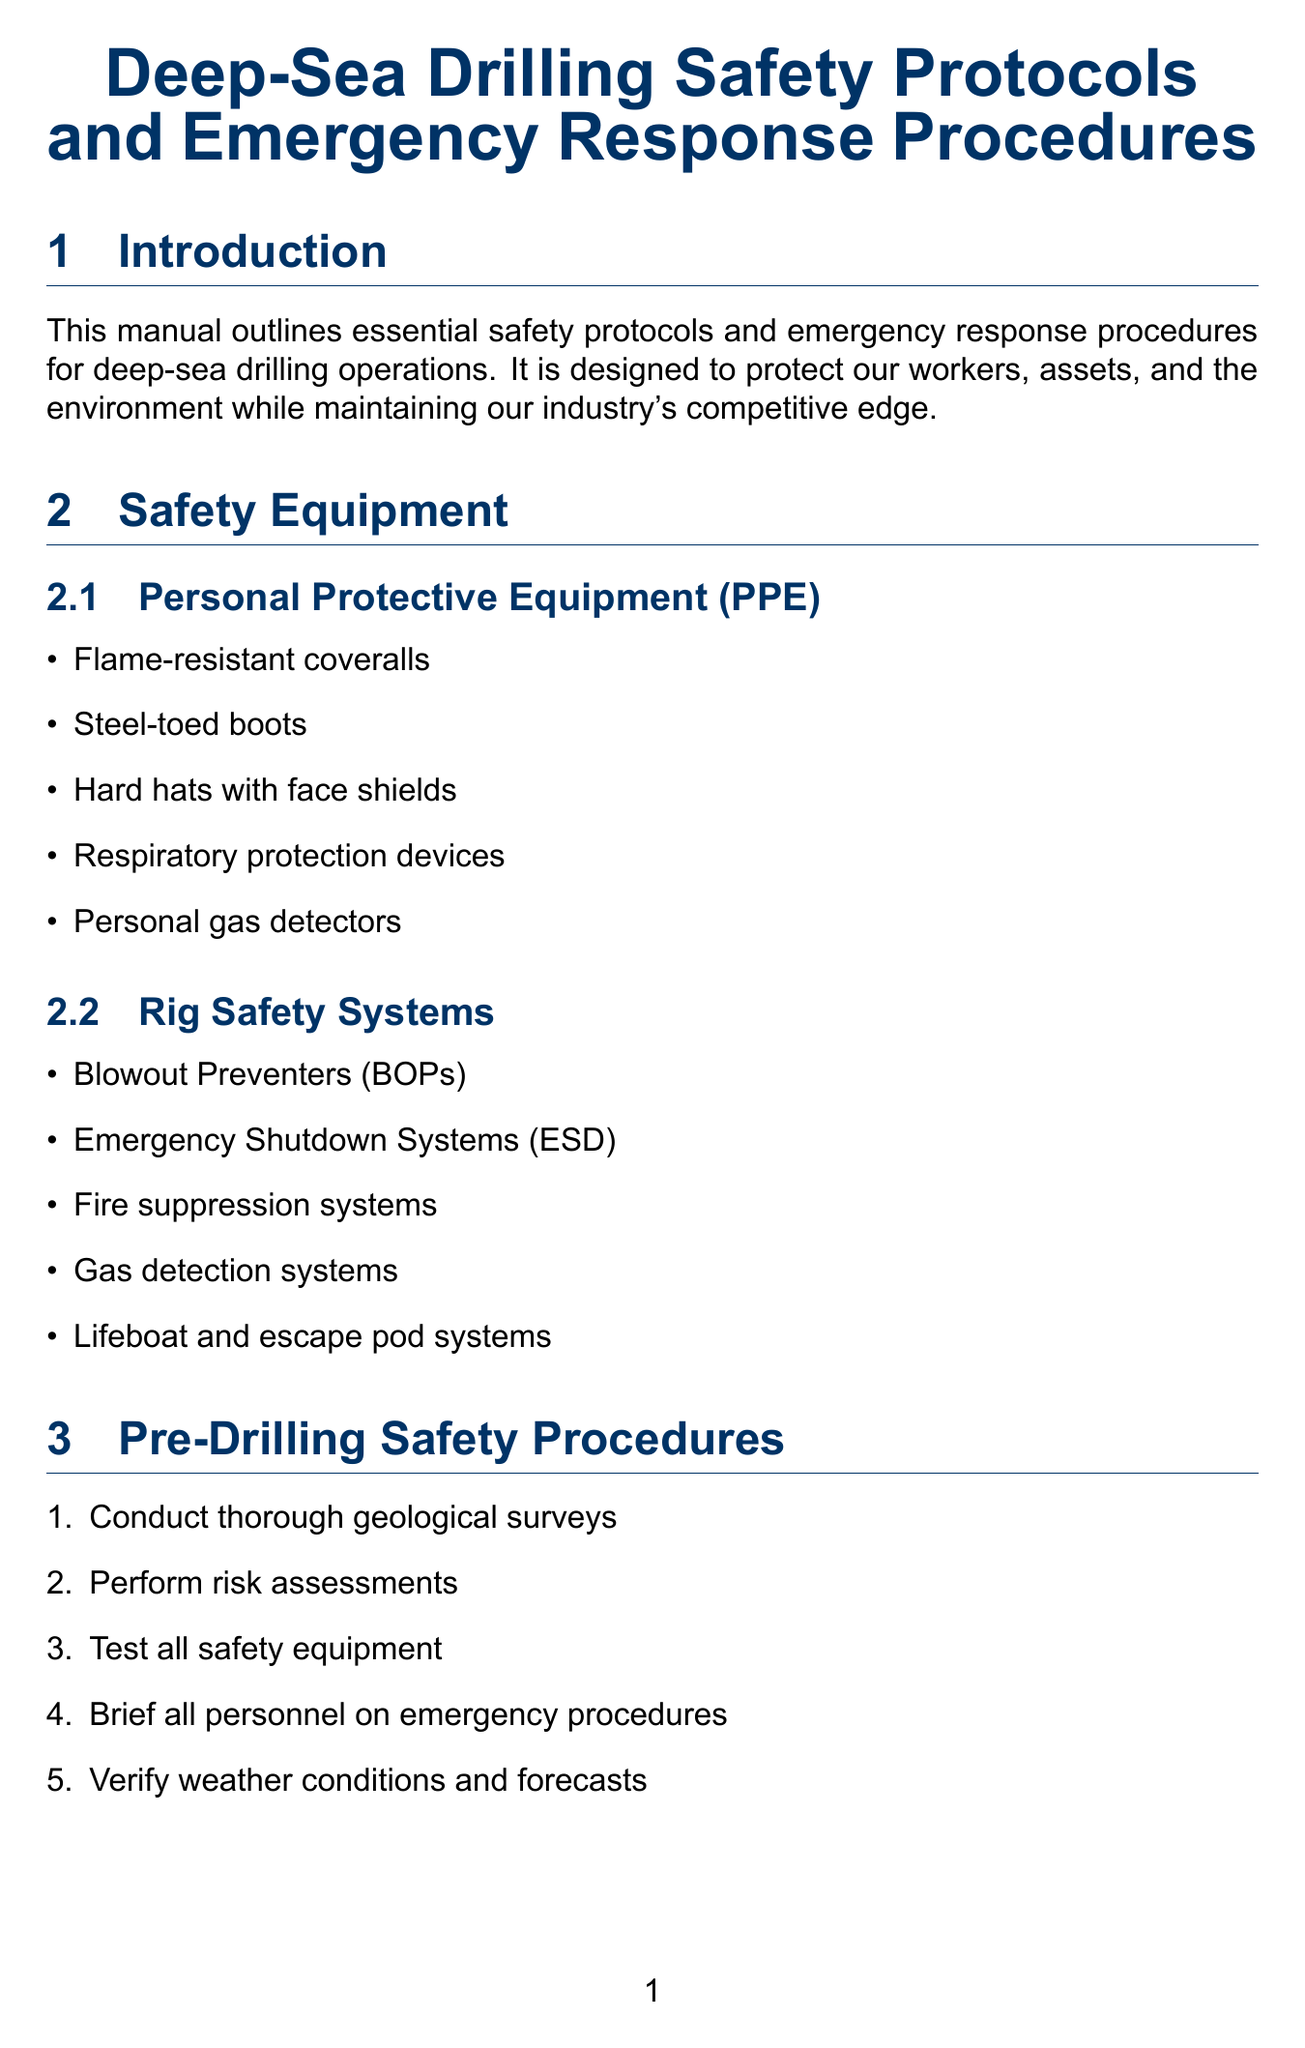what is the title of the manual? The title of the manual is given at the beginning and represents the main topic of the document.
Answer: Deep-Sea Drilling Safety Protocols and Emergency Response Procedures what type of PPE is mentioned? The manual lists specific items classified under Personal Protective Equipment in the safety equipment section.
Answer: Flame-resistant coveralls how many emergency response scenarios are detailed? The number of scenarios is found in the Emergency Response Procedures section, which lists them individually.
Answer: Three what system is engaged during a blowout? The specific system to be engaged is stated in the emergency procedures outlined for a blowout scenario.
Answer: Blowout Preventer which drilling rig class is included in the equipment diagrams? The class of the drilling rig is specified in the Equipment Diagrams section, indicating the type of equipment illustrated.
Answer: Deepwater Horizon-class which organization sets regulations applicable to operations? The organization responsible for regulations is mentioned in the Regulatory Compliance section, indicating compliance standards.
Answer: Bureau of Safety and Environmental Enforcement what is one of the training programs listed? A training program is specified in the Training and Certification section, highlighting a mandatory training requirement.
Answer: Well Control Certification how many items are listed under Environmental Protection Measures? The total number of items can be counted in the Environmental Protection Measures section where they are clearly enumerated.
Answer: Five 